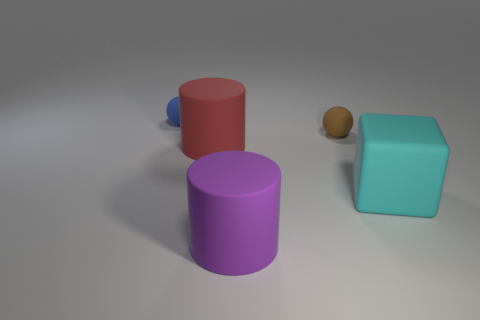Add 5 tiny brown blocks. How many objects exist? 10 Subtract all blocks. How many objects are left? 4 Subtract all red things. Subtract all tiny brown rubber objects. How many objects are left? 3 Add 5 purple rubber objects. How many purple rubber objects are left? 6 Add 4 tiny matte balls. How many tiny matte balls exist? 6 Subtract 0 brown cylinders. How many objects are left? 5 